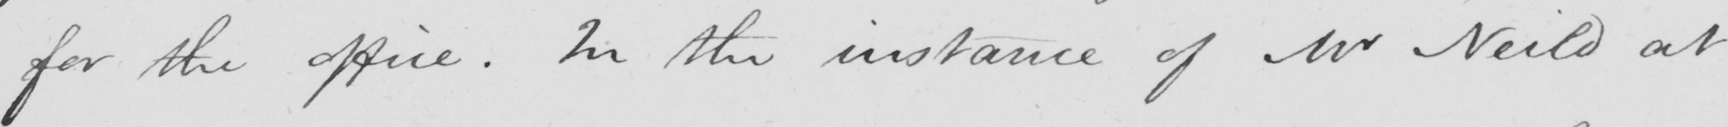What is written in this line of handwriting? for the office . In the instance of Mr Neild at 